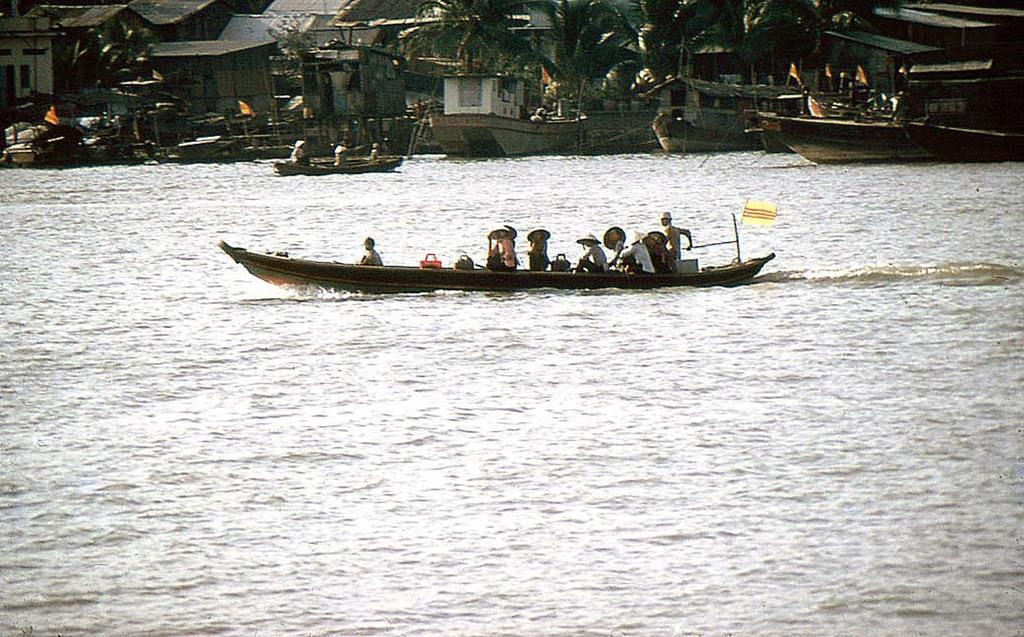What is the main subject of the image? The main subject of the image is boats. Where are the boats located? The boats are on the water. What can be seen in the background of the image? There are trees and sheds in the background of the image. Can you see any quicksand near the boats in the image? There is no quicksand present in the image. What type of grape is growing on the trees in the background? There are no grapes visible in the image, as the trees in the background are not fruit-bearing trees. 